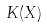<formula> <loc_0><loc_0><loc_500><loc_500>K ( X )</formula> 